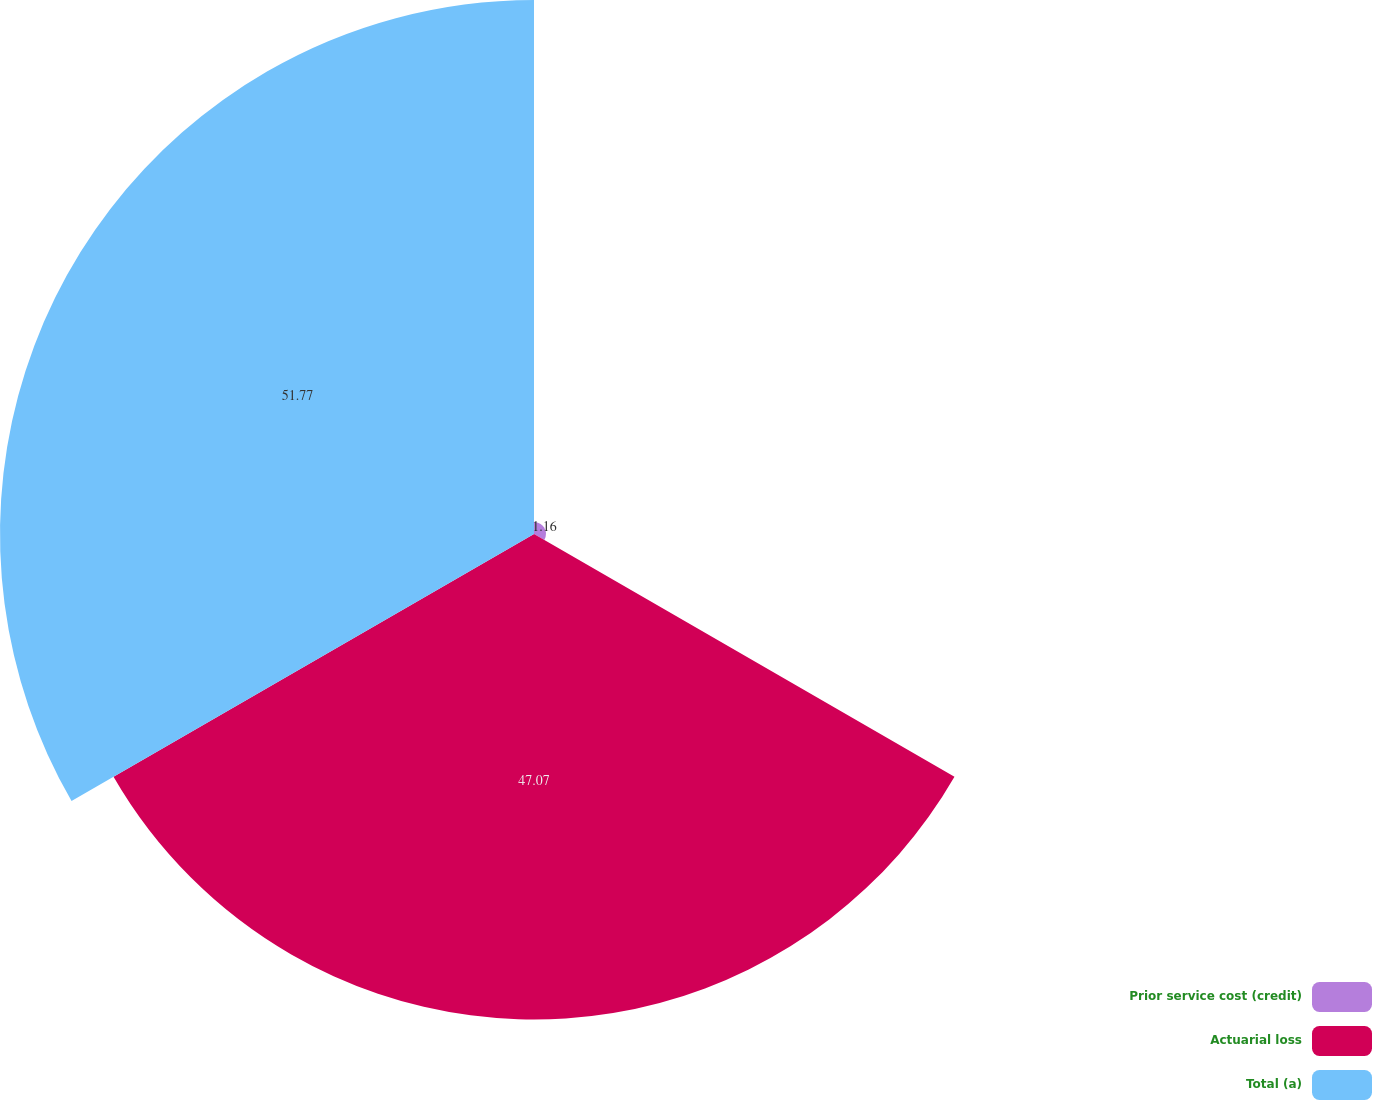Convert chart. <chart><loc_0><loc_0><loc_500><loc_500><pie_chart><fcel>Prior service cost (credit)<fcel>Actuarial loss<fcel>Total (a)<nl><fcel>1.16%<fcel>47.07%<fcel>51.77%<nl></chart> 